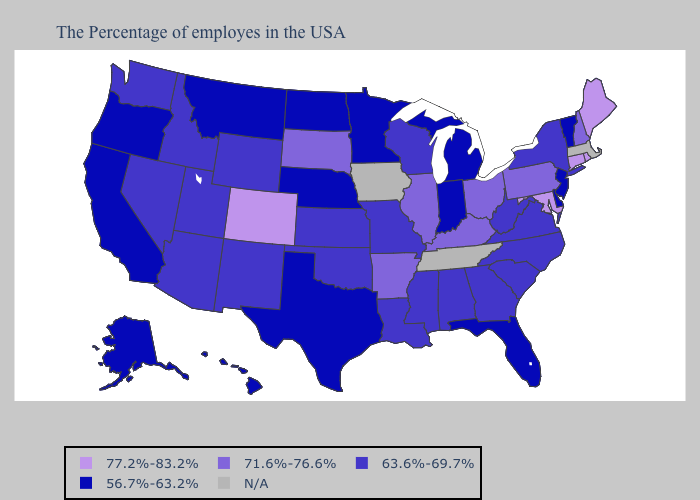What is the value of Delaware?
Quick response, please. 56.7%-63.2%. Does Florida have the highest value in the USA?
Be succinct. No. Name the states that have a value in the range 63.6%-69.7%?
Keep it brief. New York, Virginia, North Carolina, South Carolina, West Virginia, Georgia, Alabama, Wisconsin, Mississippi, Louisiana, Missouri, Kansas, Oklahoma, Wyoming, New Mexico, Utah, Arizona, Idaho, Nevada, Washington. Does Vermont have the lowest value in the Northeast?
Concise answer only. Yes. Name the states that have a value in the range 56.7%-63.2%?
Quick response, please. Vermont, New Jersey, Delaware, Florida, Michigan, Indiana, Minnesota, Nebraska, Texas, North Dakota, Montana, California, Oregon, Alaska, Hawaii. What is the value of Tennessee?
Write a very short answer. N/A. Name the states that have a value in the range 63.6%-69.7%?
Be succinct. New York, Virginia, North Carolina, South Carolina, West Virginia, Georgia, Alabama, Wisconsin, Mississippi, Louisiana, Missouri, Kansas, Oklahoma, Wyoming, New Mexico, Utah, Arizona, Idaho, Nevada, Washington. Which states hav the highest value in the West?
Write a very short answer. Colorado. Name the states that have a value in the range 56.7%-63.2%?
Short answer required. Vermont, New Jersey, Delaware, Florida, Michigan, Indiana, Minnesota, Nebraska, Texas, North Dakota, Montana, California, Oregon, Alaska, Hawaii. Which states hav the highest value in the South?
Quick response, please. Maryland. What is the lowest value in the MidWest?
Write a very short answer. 56.7%-63.2%. Which states have the highest value in the USA?
Give a very brief answer. Maine, Rhode Island, Connecticut, Maryland, Colorado. Name the states that have a value in the range 63.6%-69.7%?
Quick response, please. New York, Virginia, North Carolina, South Carolina, West Virginia, Georgia, Alabama, Wisconsin, Mississippi, Louisiana, Missouri, Kansas, Oklahoma, Wyoming, New Mexico, Utah, Arizona, Idaho, Nevada, Washington. Which states hav the highest value in the MidWest?
Quick response, please. Ohio, Illinois, South Dakota. Name the states that have a value in the range 71.6%-76.6%?
Short answer required. New Hampshire, Pennsylvania, Ohio, Kentucky, Illinois, Arkansas, South Dakota. 